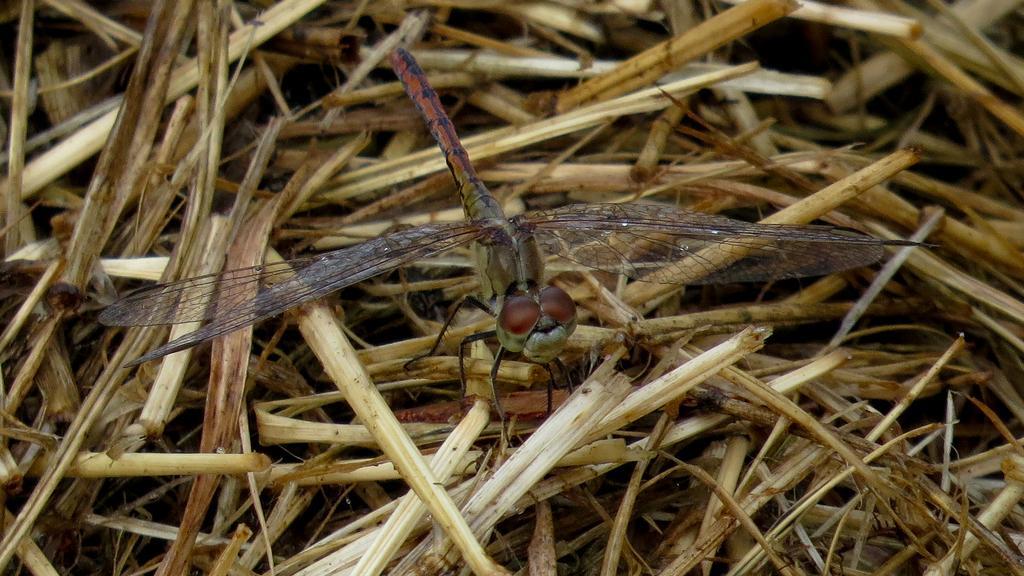Can you describe this image briefly? In the image we can see there is a dragonfly sitting on the dry plant stem. 